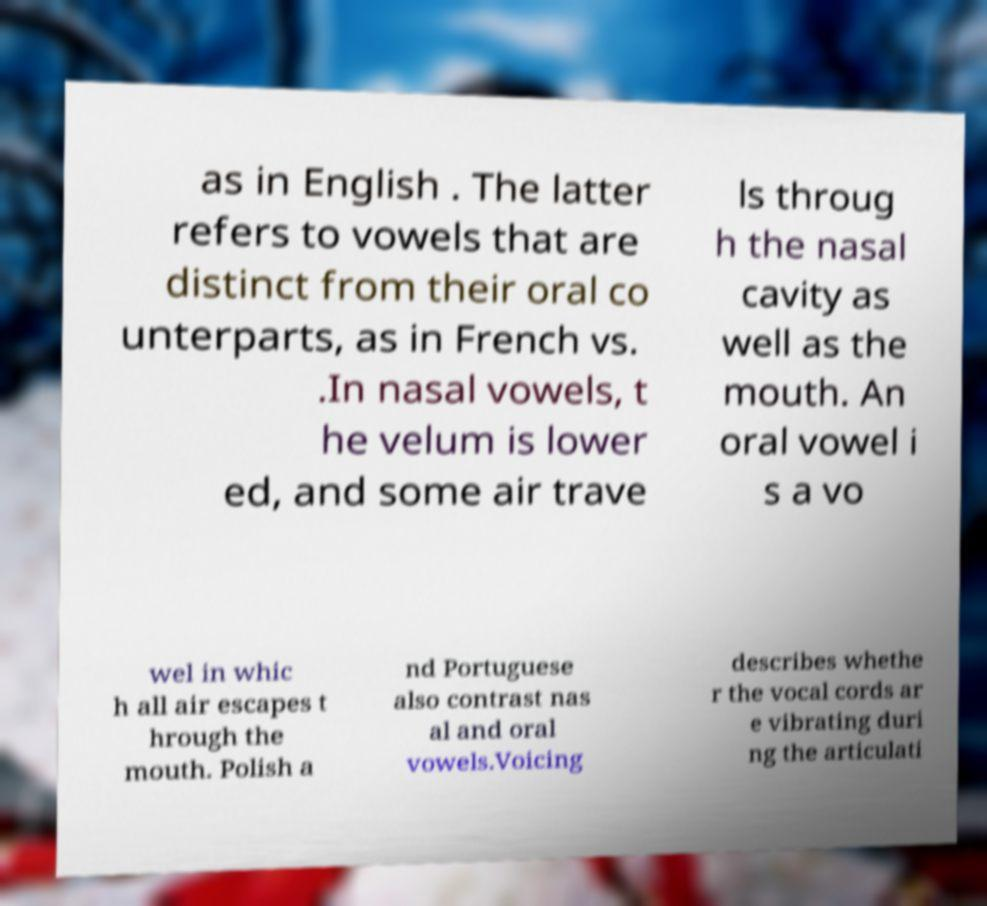Can you read and provide the text displayed in the image?This photo seems to have some interesting text. Can you extract and type it out for me? as in English . The latter refers to vowels that are distinct from their oral co unterparts, as in French vs. .In nasal vowels, t he velum is lower ed, and some air trave ls throug h the nasal cavity as well as the mouth. An oral vowel i s a vo wel in whic h all air escapes t hrough the mouth. Polish a nd Portuguese also contrast nas al and oral vowels.Voicing describes whethe r the vocal cords ar e vibrating duri ng the articulati 